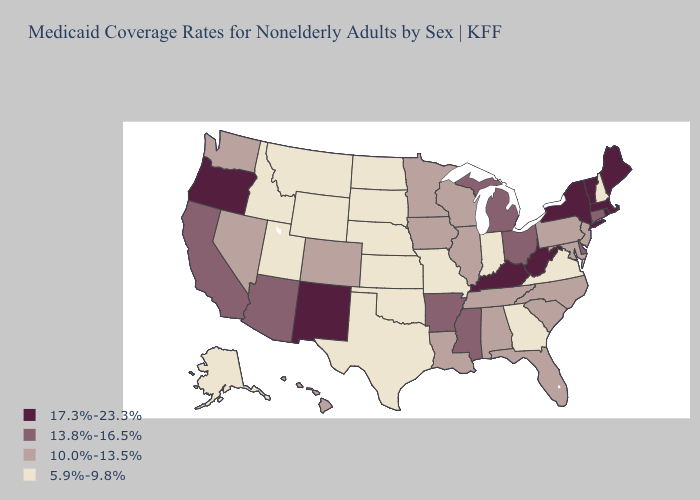Name the states that have a value in the range 17.3%-23.3%?
Quick response, please. Kentucky, Maine, Massachusetts, New Mexico, New York, Oregon, Rhode Island, Vermont, West Virginia. What is the lowest value in the Northeast?
Be succinct. 5.9%-9.8%. Name the states that have a value in the range 17.3%-23.3%?
Be succinct. Kentucky, Maine, Massachusetts, New Mexico, New York, Oregon, Rhode Island, Vermont, West Virginia. Which states have the lowest value in the USA?
Be succinct. Alaska, Georgia, Idaho, Indiana, Kansas, Missouri, Montana, Nebraska, New Hampshire, North Dakota, Oklahoma, South Dakota, Texas, Utah, Virginia, Wyoming. What is the value of Virginia?
Short answer required. 5.9%-9.8%. Name the states that have a value in the range 13.8%-16.5%?
Short answer required. Arizona, Arkansas, California, Connecticut, Delaware, Michigan, Mississippi, Ohio. What is the lowest value in the South?
Answer briefly. 5.9%-9.8%. Name the states that have a value in the range 13.8%-16.5%?
Keep it brief. Arizona, Arkansas, California, Connecticut, Delaware, Michigan, Mississippi, Ohio. Which states have the lowest value in the USA?
Keep it brief. Alaska, Georgia, Idaho, Indiana, Kansas, Missouri, Montana, Nebraska, New Hampshire, North Dakota, Oklahoma, South Dakota, Texas, Utah, Virginia, Wyoming. How many symbols are there in the legend?
Short answer required. 4. Among the states that border Kentucky , which have the lowest value?
Give a very brief answer. Indiana, Missouri, Virginia. Name the states that have a value in the range 13.8%-16.5%?
Quick response, please. Arizona, Arkansas, California, Connecticut, Delaware, Michigan, Mississippi, Ohio. What is the lowest value in the USA?
Give a very brief answer. 5.9%-9.8%. Does Maine have the highest value in the USA?
Short answer required. Yes. Does New Jersey have a lower value than Hawaii?
Short answer required. No. 